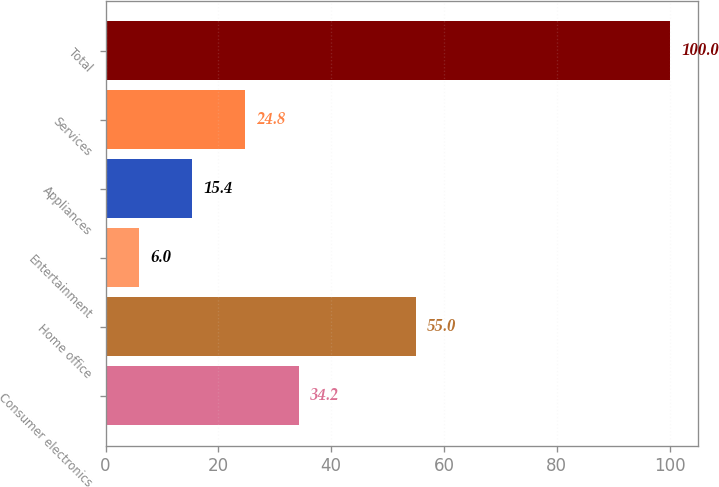Convert chart to OTSL. <chart><loc_0><loc_0><loc_500><loc_500><bar_chart><fcel>Consumer electronics<fcel>Home office<fcel>Entertainment<fcel>Appliances<fcel>Services<fcel>Total<nl><fcel>34.2<fcel>55<fcel>6<fcel>15.4<fcel>24.8<fcel>100<nl></chart> 